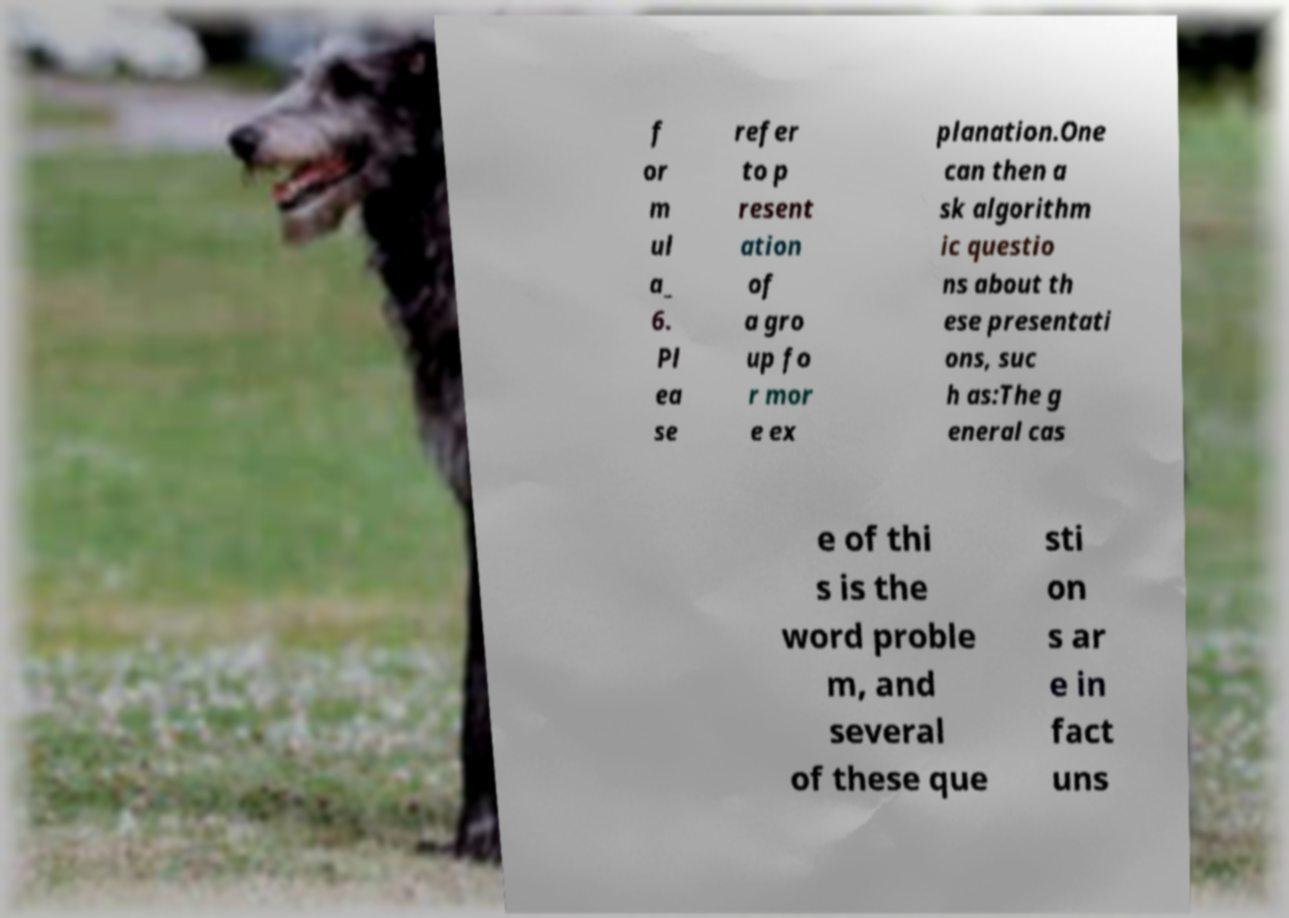Please read and relay the text visible in this image. What does it say? f or m ul a_ 6. Pl ea se refer to p resent ation of a gro up fo r mor e ex planation.One can then a sk algorithm ic questio ns about th ese presentati ons, suc h as:The g eneral cas e of thi s is the word proble m, and several of these que sti on s ar e in fact uns 